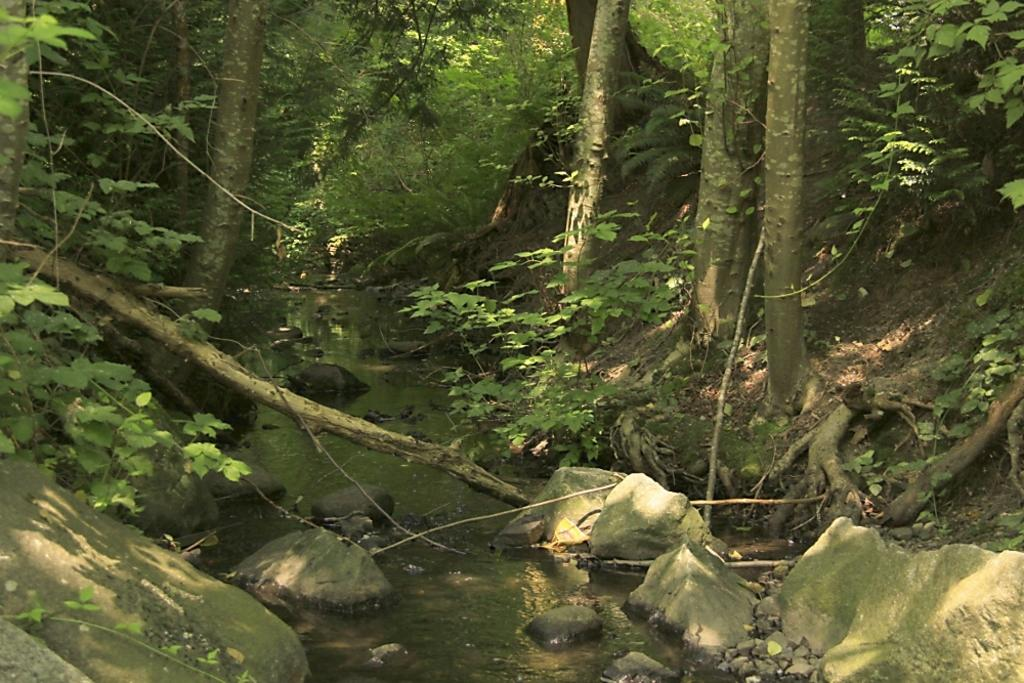What type of natural elements can be seen in the image? There are rocks and stones in the image. What else is visible in the image besides rocks and stones? There is water and plants visible in the image. What can be seen in the background of the image? There are trees in the background of the image. What type of club is being used to hit the rocks in the image? There is no club present in the image, and the rocks are not being hit. 